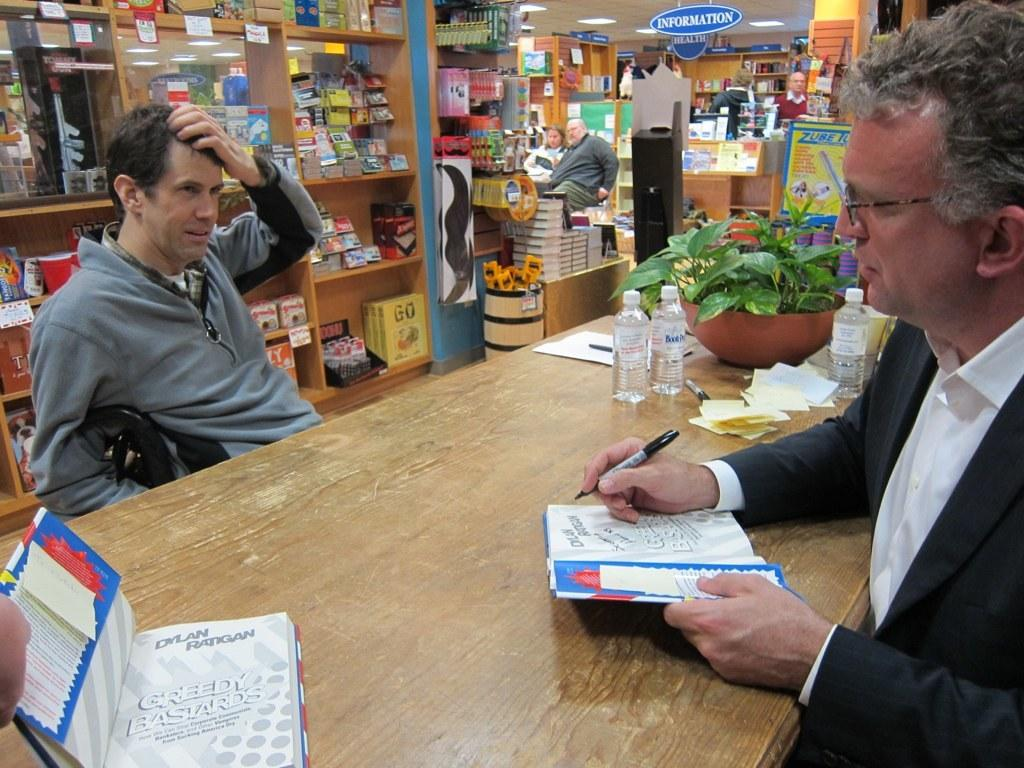<image>
Relay a brief, clear account of the picture shown. A man signing books authored by Dylan Ratigan with the name Greedy Bastards. 